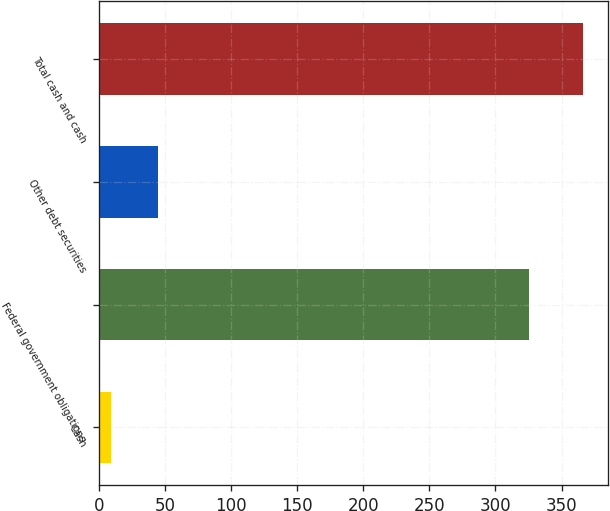<chart> <loc_0><loc_0><loc_500><loc_500><bar_chart><fcel>Cash<fcel>Federal government obligations<fcel>Other debt securities<fcel>Total cash and cash<nl><fcel>9.1<fcel>325.4<fcel>44.84<fcel>366.5<nl></chart> 